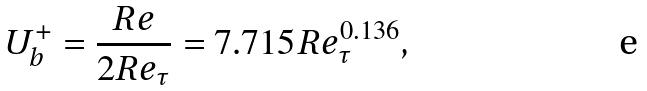Convert formula to latex. <formula><loc_0><loc_0><loc_500><loc_500>U _ { b } ^ { + } = \frac { R e } { 2 R e _ { \tau } } = 7 . 7 1 5 R e _ { \tau } ^ { 0 . 1 3 6 } ,</formula> 